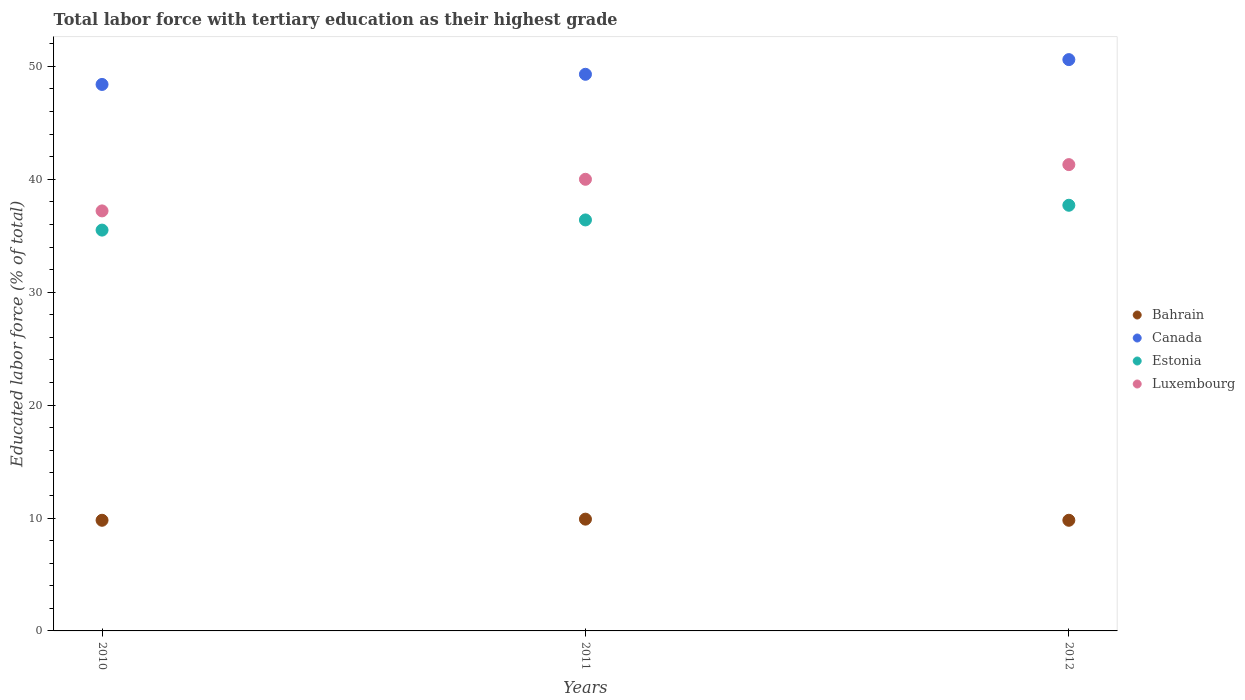How many different coloured dotlines are there?
Your response must be concise. 4. Is the number of dotlines equal to the number of legend labels?
Offer a terse response. Yes. What is the percentage of male labor force with tertiary education in Estonia in 2010?
Provide a short and direct response. 35.5. Across all years, what is the maximum percentage of male labor force with tertiary education in Canada?
Give a very brief answer. 50.6. Across all years, what is the minimum percentage of male labor force with tertiary education in Canada?
Ensure brevity in your answer.  48.4. In which year was the percentage of male labor force with tertiary education in Luxembourg maximum?
Make the answer very short. 2012. What is the total percentage of male labor force with tertiary education in Estonia in the graph?
Provide a succinct answer. 109.6. What is the difference between the percentage of male labor force with tertiary education in Estonia in 2010 and that in 2011?
Your answer should be compact. -0.9. What is the difference between the percentage of male labor force with tertiary education in Canada in 2010 and the percentage of male labor force with tertiary education in Bahrain in 2012?
Your answer should be very brief. 38.6. What is the average percentage of male labor force with tertiary education in Estonia per year?
Give a very brief answer. 36.53. In the year 2010, what is the difference between the percentage of male labor force with tertiary education in Luxembourg and percentage of male labor force with tertiary education in Estonia?
Ensure brevity in your answer.  1.7. In how many years, is the percentage of male labor force with tertiary education in Estonia greater than 22 %?
Offer a terse response. 3. What is the ratio of the percentage of male labor force with tertiary education in Canada in 2010 to that in 2011?
Give a very brief answer. 0.98. Is the difference between the percentage of male labor force with tertiary education in Luxembourg in 2011 and 2012 greater than the difference between the percentage of male labor force with tertiary education in Estonia in 2011 and 2012?
Your response must be concise. Yes. What is the difference between the highest and the second highest percentage of male labor force with tertiary education in Estonia?
Give a very brief answer. 1.3. What is the difference between the highest and the lowest percentage of male labor force with tertiary education in Estonia?
Keep it short and to the point. 2.2. Is the sum of the percentage of male labor force with tertiary education in Bahrain in 2010 and 2011 greater than the maximum percentage of male labor force with tertiary education in Canada across all years?
Provide a succinct answer. No. Is it the case that in every year, the sum of the percentage of male labor force with tertiary education in Luxembourg and percentage of male labor force with tertiary education in Bahrain  is greater than the sum of percentage of male labor force with tertiary education in Canada and percentage of male labor force with tertiary education in Estonia?
Make the answer very short. No. Is it the case that in every year, the sum of the percentage of male labor force with tertiary education in Canada and percentage of male labor force with tertiary education in Estonia  is greater than the percentage of male labor force with tertiary education in Luxembourg?
Ensure brevity in your answer.  Yes. Is the percentage of male labor force with tertiary education in Estonia strictly greater than the percentage of male labor force with tertiary education in Bahrain over the years?
Your response must be concise. Yes. Does the graph contain any zero values?
Your answer should be very brief. No. Where does the legend appear in the graph?
Your answer should be very brief. Center right. What is the title of the graph?
Provide a succinct answer. Total labor force with tertiary education as their highest grade. Does "Botswana" appear as one of the legend labels in the graph?
Ensure brevity in your answer.  No. What is the label or title of the X-axis?
Give a very brief answer. Years. What is the label or title of the Y-axis?
Ensure brevity in your answer.  Educated labor force (% of total). What is the Educated labor force (% of total) in Bahrain in 2010?
Provide a short and direct response. 9.8. What is the Educated labor force (% of total) of Canada in 2010?
Ensure brevity in your answer.  48.4. What is the Educated labor force (% of total) in Estonia in 2010?
Give a very brief answer. 35.5. What is the Educated labor force (% of total) of Luxembourg in 2010?
Your response must be concise. 37.2. What is the Educated labor force (% of total) in Bahrain in 2011?
Provide a short and direct response. 9.9. What is the Educated labor force (% of total) in Canada in 2011?
Your answer should be very brief. 49.3. What is the Educated labor force (% of total) of Estonia in 2011?
Offer a very short reply. 36.4. What is the Educated labor force (% of total) in Luxembourg in 2011?
Your response must be concise. 40. What is the Educated labor force (% of total) of Bahrain in 2012?
Your answer should be very brief. 9.8. What is the Educated labor force (% of total) of Canada in 2012?
Offer a very short reply. 50.6. What is the Educated labor force (% of total) in Estonia in 2012?
Keep it short and to the point. 37.7. What is the Educated labor force (% of total) in Luxembourg in 2012?
Give a very brief answer. 41.3. Across all years, what is the maximum Educated labor force (% of total) of Bahrain?
Your answer should be very brief. 9.9. Across all years, what is the maximum Educated labor force (% of total) in Canada?
Provide a short and direct response. 50.6. Across all years, what is the maximum Educated labor force (% of total) in Estonia?
Ensure brevity in your answer.  37.7. Across all years, what is the maximum Educated labor force (% of total) in Luxembourg?
Your answer should be compact. 41.3. Across all years, what is the minimum Educated labor force (% of total) in Bahrain?
Make the answer very short. 9.8. Across all years, what is the minimum Educated labor force (% of total) of Canada?
Give a very brief answer. 48.4. Across all years, what is the minimum Educated labor force (% of total) in Estonia?
Provide a succinct answer. 35.5. Across all years, what is the minimum Educated labor force (% of total) in Luxembourg?
Make the answer very short. 37.2. What is the total Educated labor force (% of total) of Bahrain in the graph?
Give a very brief answer. 29.5. What is the total Educated labor force (% of total) in Canada in the graph?
Provide a succinct answer. 148.3. What is the total Educated labor force (% of total) of Estonia in the graph?
Keep it short and to the point. 109.6. What is the total Educated labor force (% of total) in Luxembourg in the graph?
Give a very brief answer. 118.5. What is the difference between the Educated labor force (% of total) of Estonia in 2010 and that in 2011?
Offer a very short reply. -0.9. What is the difference between the Educated labor force (% of total) of Luxembourg in 2010 and that in 2011?
Your answer should be very brief. -2.8. What is the difference between the Educated labor force (% of total) in Bahrain in 2010 and that in 2012?
Offer a very short reply. 0. What is the difference between the Educated labor force (% of total) of Canada in 2010 and that in 2012?
Your answer should be compact. -2.2. What is the difference between the Educated labor force (% of total) of Luxembourg in 2010 and that in 2012?
Make the answer very short. -4.1. What is the difference between the Educated labor force (% of total) of Bahrain in 2011 and that in 2012?
Offer a terse response. 0.1. What is the difference between the Educated labor force (% of total) in Canada in 2011 and that in 2012?
Keep it short and to the point. -1.3. What is the difference between the Educated labor force (% of total) of Estonia in 2011 and that in 2012?
Give a very brief answer. -1.3. What is the difference between the Educated labor force (% of total) of Bahrain in 2010 and the Educated labor force (% of total) of Canada in 2011?
Offer a terse response. -39.5. What is the difference between the Educated labor force (% of total) of Bahrain in 2010 and the Educated labor force (% of total) of Estonia in 2011?
Keep it short and to the point. -26.6. What is the difference between the Educated labor force (% of total) of Bahrain in 2010 and the Educated labor force (% of total) of Luxembourg in 2011?
Offer a terse response. -30.2. What is the difference between the Educated labor force (% of total) in Canada in 2010 and the Educated labor force (% of total) in Luxembourg in 2011?
Provide a short and direct response. 8.4. What is the difference between the Educated labor force (% of total) of Estonia in 2010 and the Educated labor force (% of total) of Luxembourg in 2011?
Make the answer very short. -4.5. What is the difference between the Educated labor force (% of total) of Bahrain in 2010 and the Educated labor force (% of total) of Canada in 2012?
Ensure brevity in your answer.  -40.8. What is the difference between the Educated labor force (% of total) in Bahrain in 2010 and the Educated labor force (% of total) in Estonia in 2012?
Provide a succinct answer. -27.9. What is the difference between the Educated labor force (% of total) of Bahrain in 2010 and the Educated labor force (% of total) of Luxembourg in 2012?
Provide a succinct answer. -31.5. What is the difference between the Educated labor force (% of total) in Canada in 2010 and the Educated labor force (% of total) in Estonia in 2012?
Provide a short and direct response. 10.7. What is the difference between the Educated labor force (% of total) of Canada in 2010 and the Educated labor force (% of total) of Luxembourg in 2012?
Make the answer very short. 7.1. What is the difference between the Educated labor force (% of total) in Bahrain in 2011 and the Educated labor force (% of total) in Canada in 2012?
Your answer should be very brief. -40.7. What is the difference between the Educated labor force (% of total) in Bahrain in 2011 and the Educated labor force (% of total) in Estonia in 2012?
Keep it short and to the point. -27.8. What is the difference between the Educated labor force (% of total) of Bahrain in 2011 and the Educated labor force (% of total) of Luxembourg in 2012?
Your response must be concise. -31.4. What is the difference between the Educated labor force (% of total) of Canada in 2011 and the Educated labor force (% of total) of Luxembourg in 2012?
Your response must be concise. 8. What is the difference between the Educated labor force (% of total) in Estonia in 2011 and the Educated labor force (% of total) in Luxembourg in 2012?
Your response must be concise. -4.9. What is the average Educated labor force (% of total) of Bahrain per year?
Give a very brief answer. 9.83. What is the average Educated labor force (% of total) in Canada per year?
Offer a terse response. 49.43. What is the average Educated labor force (% of total) in Estonia per year?
Offer a terse response. 36.53. What is the average Educated labor force (% of total) in Luxembourg per year?
Provide a short and direct response. 39.5. In the year 2010, what is the difference between the Educated labor force (% of total) of Bahrain and Educated labor force (% of total) of Canada?
Offer a very short reply. -38.6. In the year 2010, what is the difference between the Educated labor force (% of total) in Bahrain and Educated labor force (% of total) in Estonia?
Offer a very short reply. -25.7. In the year 2010, what is the difference between the Educated labor force (% of total) in Bahrain and Educated labor force (% of total) in Luxembourg?
Provide a short and direct response. -27.4. In the year 2010, what is the difference between the Educated labor force (% of total) of Canada and Educated labor force (% of total) of Luxembourg?
Give a very brief answer. 11.2. In the year 2011, what is the difference between the Educated labor force (% of total) in Bahrain and Educated labor force (% of total) in Canada?
Make the answer very short. -39.4. In the year 2011, what is the difference between the Educated labor force (% of total) in Bahrain and Educated labor force (% of total) in Estonia?
Make the answer very short. -26.5. In the year 2011, what is the difference between the Educated labor force (% of total) in Bahrain and Educated labor force (% of total) in Luxembourg?
Make the answer very short. -30.1. In the year 2011, what is the difference between the Educated labor force (% of total) in Estonia and Educated labor force (% of total) in Luxembourg?
Give a very brief answer. -3.6. In the year 2012, what is the difference between the Educated labor force (% of total) of Bahrain and Educated labor force (% of total) of Canada?
Your response must be concise. -40.8. In the year 2012, what is the difference between the Educated labor force (% of total) of Bahrain and Educated labor force (% of total) of Estonia?
Your response must be concise. -27.9. In the year 2012, what is the difference between the Educated labor force (% of total) in Bahrain and Educated labor force (% of total) in Luxembourg?
Your response must be concise. -31.5. What is the ratio of the Educated labor force (% of total) of Canada in 2010 to that in 2011?
Provide a short and direct response. 0.98. What is the ratio of the Educated labor force (% of total) of Estonia in 2010 to that in 2011?
Your answer should be compact. 0.98. What is the ratio of the Educated labor force (% of total) of Luxembourg in 2010 to that in 2011?
Offer a terse response. 0.93. What is the ratio of the Educated labor force (% of total) of Bahrain in 2010 to that in 2012?
Make the answer very short. 1. What is the ratio of the Educated labor force (% of total) of Canada in 2010 to that in 2012?
Your answer should be very brief. 0.96. What is the ratio of the Educated labor force (% of total) of Estonia in 2010 to that in 2012?
Give a very brief answer. 0.94. What is the ratio of the Educated labor force (% of total) of Luxembourg in 2010 to that in 2012?
Provide a short and direct response. 0.9. What is the ratio of the Educated labor force (% of total) of Bahrain in 2011 to that in 2012?
Your response must be concise. 1.01. What is the ratio of the Educated labor force (% of total) in Canada in 2011 to that in 2012?
Keep it short and to the point. 0.97. What is the ratio of the Educated labor force (% of total) of Estonia in 2011 to that in 2012?
Offer a very short reply. 0.97. What is the ratio of the Educated labor force (% of total) of Luxembourg in 2011 to that in 2012?
Provide a short and direct response. 0.97. What is the difference between the highest and the second highest Educated labor force (% of total) of Bahrain?
Offer a very short reply. 0.1. What is the difference between the highest and the second highest Educated labor force (% of total) in Luxembourg?
Ensure brevity in your answer.  1.3. 